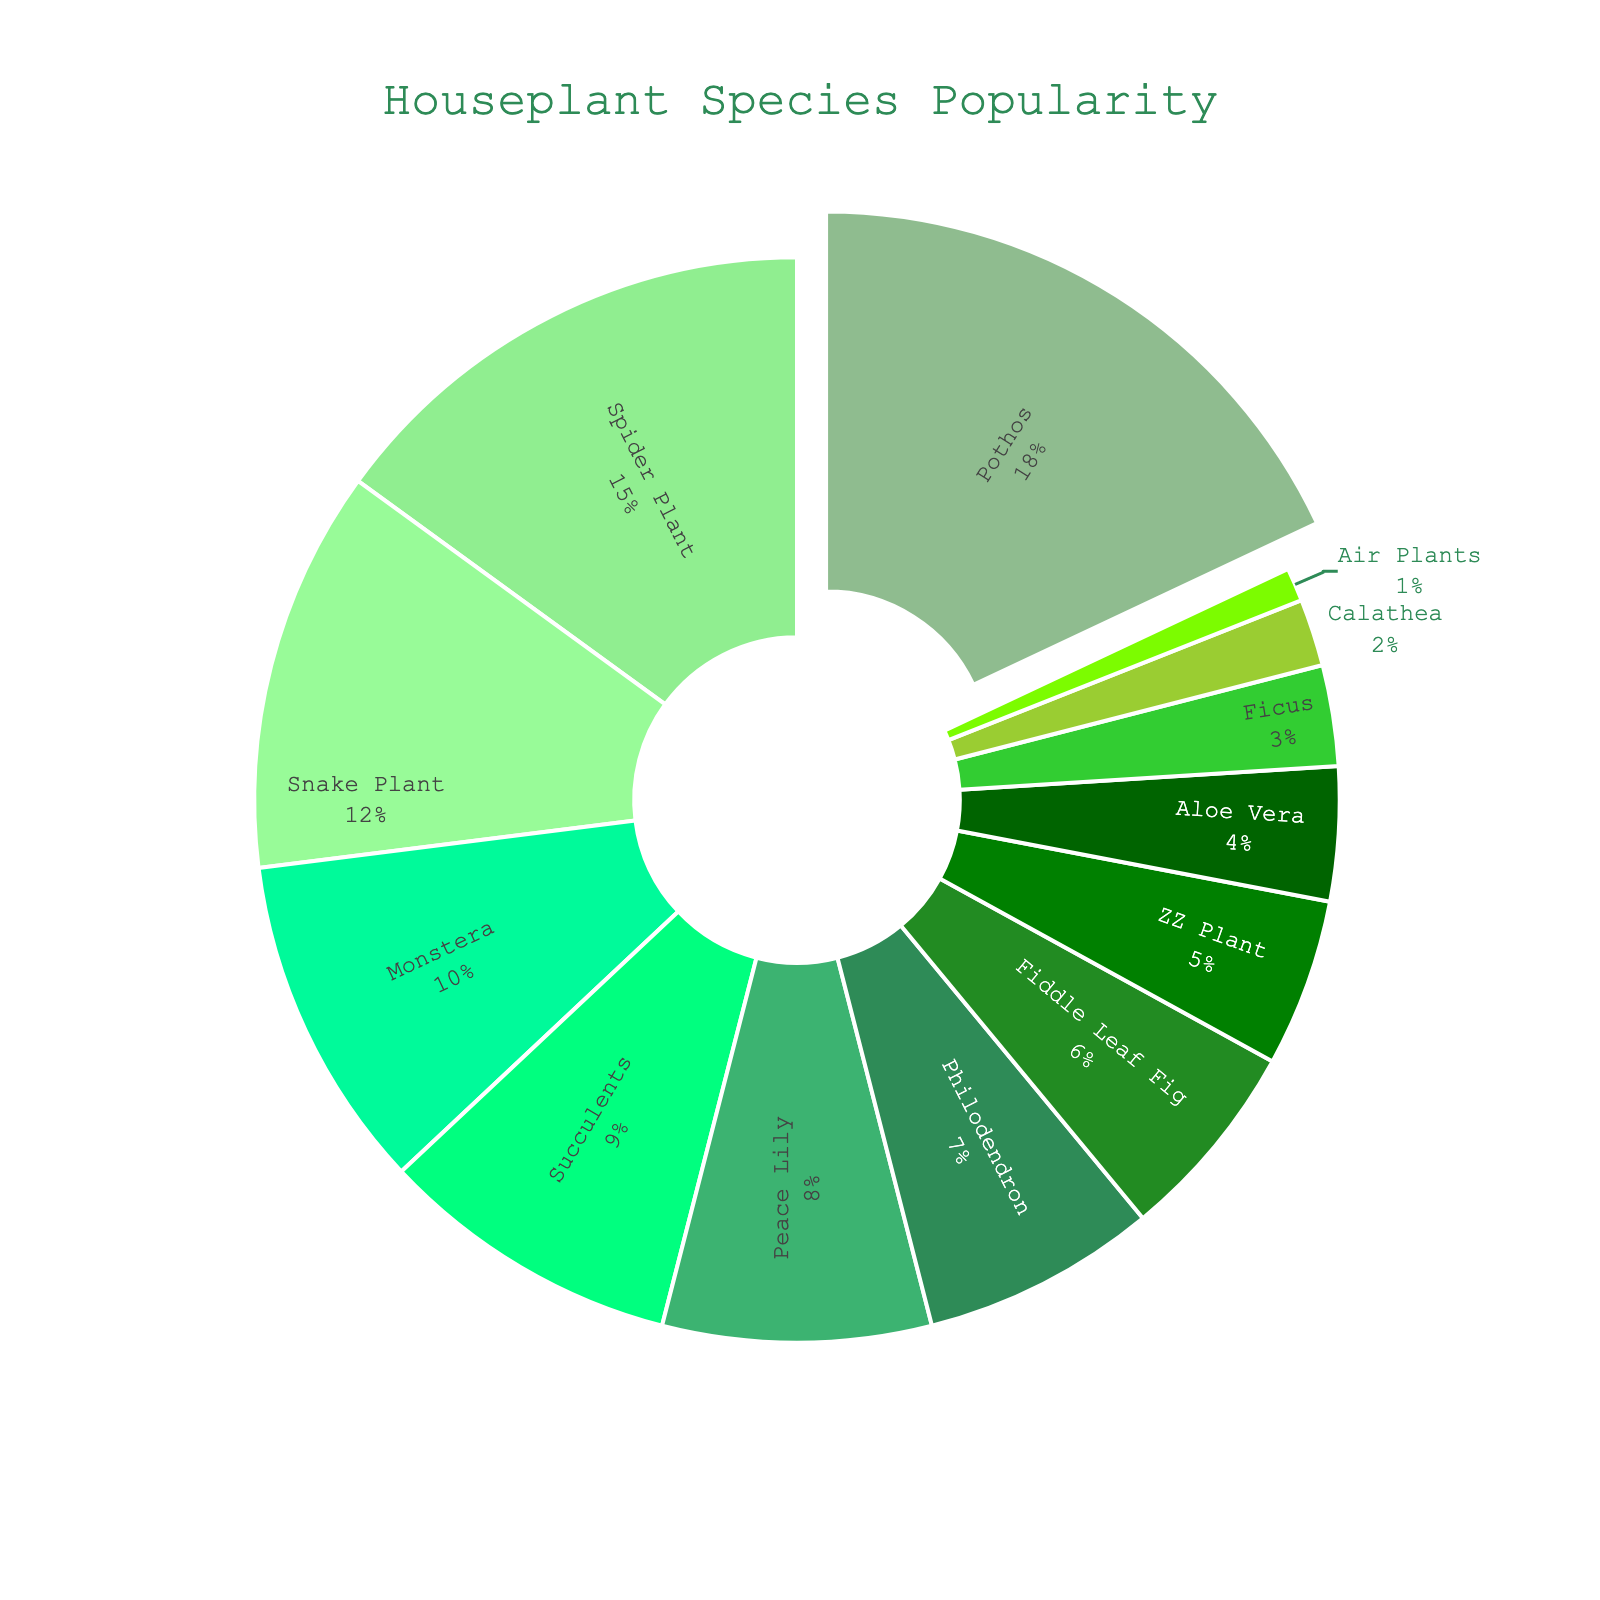Which species has the largest proportion of ownership? The species with the largest segment in the pie chart is pulled out slightly. By observing the chart, we can see that Pothos has the largest proportion.
Answer: Pothos How much more popular are Pothos compared to Succulents? The percentage for Pothos is 18% and for Succulents is 9%. The difference is calculated as 18% - 9%.
Answer: 9% What is the combined percentage of Spider Plant and Snake Plant ownership? Add the percentages of Spider Plant (15%) and Snake Plant (12%). The combined ownership percentage is 15% + 12%.
Answer: 27% Which species has a lower proportion of ownership: ZZ Plant or Peace Lily? Compare the segment sizes of ZZ Plant (5%) and Peace Lily (8%) on the pie chart.
Answer: ZZ Plant What is the percentage difference between the Fiddle Leaf Fig and Aloe Vera ownership? The percentages for Fiddle Leaf Fig and Aloe Vera are 6% and 4% respectively. The difference is 6% - 4%.
Answer: 2% How many species have an ownership percentage less than 5%? Count the segments in the pie chart that represent 5% or less: ZZ Plant (5%), Aloe Vera (4%), Ficus (3%), Calathea (2%), and Air Plants (1%).
Answer: 5 species Which species have the closest ownership percentages? Observing the pie chart, the species with the closest percentages are Peace Lily (8%) and Philodendron (7%), with only a 1% difference.
Answer: Peace Lily and Philodendron What is the total percentage of ownership for the top three species? The percentages for the top three species (Pothos, Spider Plant, and Snake Plant) are 18%, 15%, and 12% respectively. Add these together: 18% + 15% + 12%.
Answer: 45% How much more popular are the top two species compared to the bottom two species? The top two species are Pothos (18%) and Spider Plant (15%), and the bottom two species are Calathea (2%) and Air Plants (1%). First, sum up the top two: 18% + 15% = 33%. Then, sum up the bottom two: 2% + 1% = 3%. Finally, calculate the difference: 33% - 3%.
Answer: 30% What is the average ownership percentage of Monstera, Peace Lily, and Philodendron? The percentages are Monstera (10%), Peace Lily (8%), and Philodendron (7%). First, sum these values: 10% + 8% + 7% = 25%. Then, divide by the number of species: 25% / 3.
Answer: 8.33% 